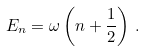<formula> <loc_0><loc_0><loc_500><loc_500>E _ { n } = \omega \left ( n + \frac { 1 } { 2 } \right ) \, .</formula> 